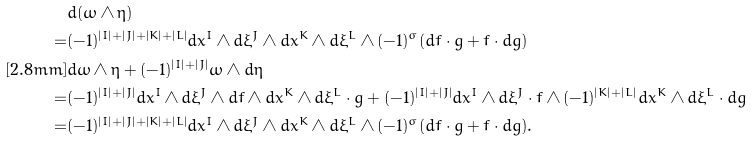Convert formula to latex. <formula><loc_0><loc_0><loc_500><loc_500>& d ( \omega \wedge \eta ) \\ = & ( - 1 ) ^ { | I | + | J | + | K | + | L | } d x ^ { I } \wedge d \xi ^ { J } \wedge d x ^ { K } \wedge d \xi ^ { L } \wedge ( - 1 ) ^ { \sigma } ( d f \cdot g + f \cdot d g ) \\ [ 2 . 8 m m ] & d \omega \wedge \eta + ( - 1 ) ^ { | I | + | J | } \omega \wedge d \eta \\ = & ( - 1 ) ^ { | I | + | J | } d x ^ { I } \wedge d \xi ^ { J } \wedge d f \wedge d x ^ { K } \wedge d \xi ^ { L } \cdot g + ( - 1 ) ^ { | I | + | J | } d x ^ { I } \wedge d \xi ^ { J } \cdot f \wedge ( - 1 ) ^ { | K | + | L | } d x ^ { K } \wedge d \xi ^ { L } \cdot d g \\ = & ( - 1 ) ^ { | I | + | J | + | K | + | L | } d x ^ { I } \wedge d \xi ^ { J } \wedge d x ^ { K } \wedge d \xi ^ { L } \wedge ( - 1 ) ^ { \sigma } ( d f \cdot g + f \cdot d g ) .</formula> 